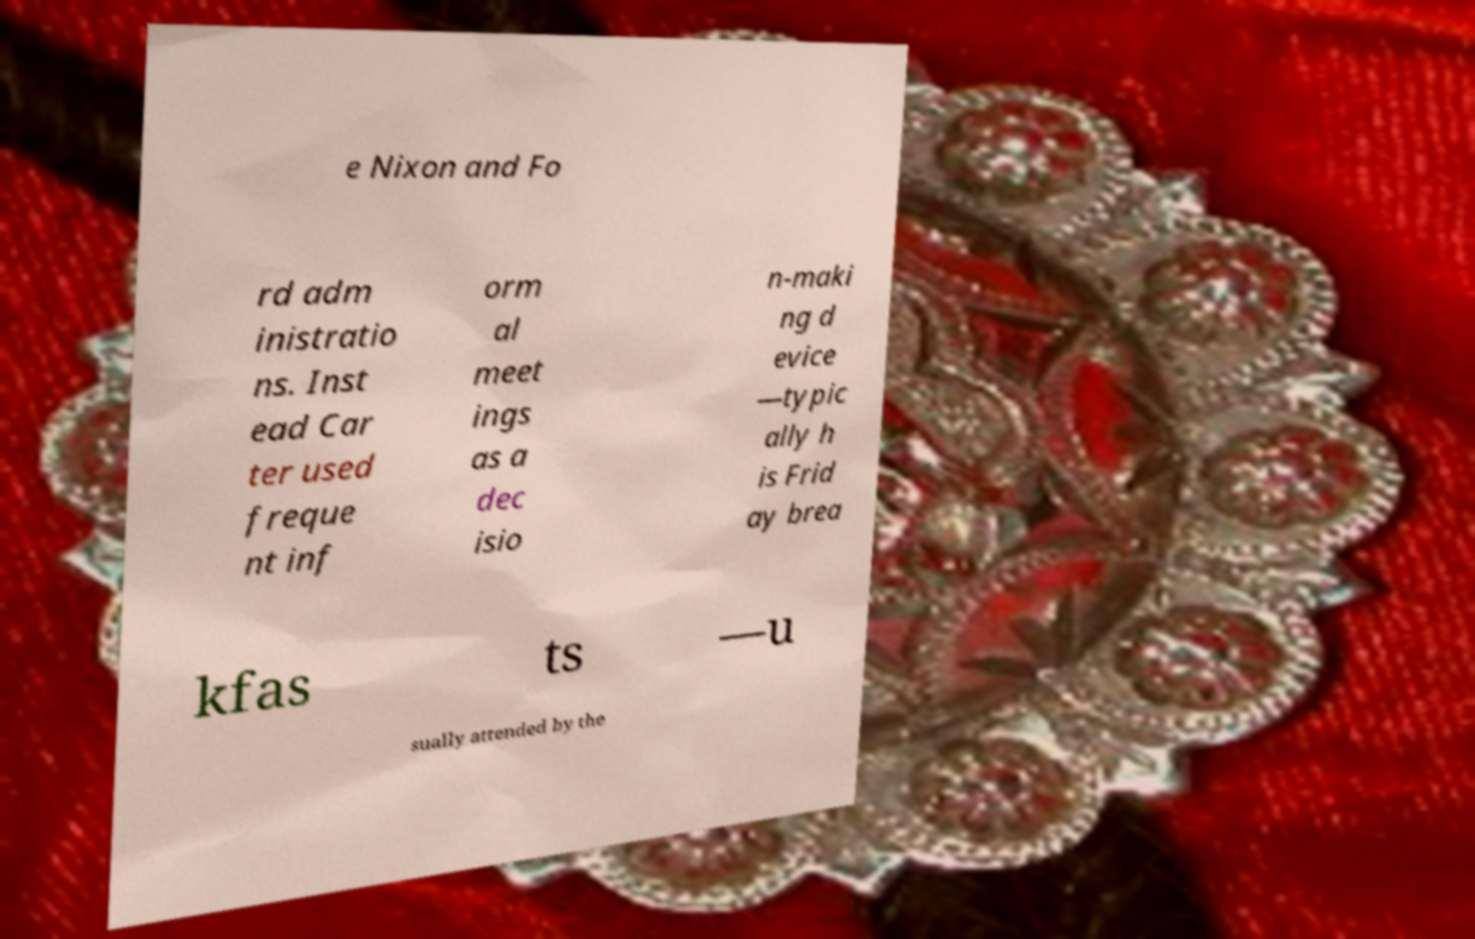There's text embedded in this image that I need extracted. Can you transcribe it verbatim? e Nixon and Fo rd adm inistratio ns. Inst ead Car ter used freque nt inf orm al meet ings as a dec isio n-maki ng d evice —typic ally h is Frid ay brea kfas ts —u sually attended by the 